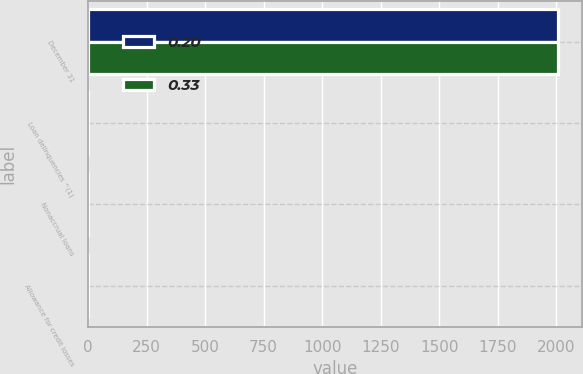Convert chart. <chart><loc_0><loc_0><loc_500><loc_500><stacked_bar_chart><ecel><fcel>December 31<fcel>Loan delinquencies ^(1)<fcel>Nonaccrual loans<fcel>Allowance for credit losses<nl><fcel>0.2<fcel>2008<fcel>0.54<fcel>0.13<fcel>0.33<nl><fcel>0.33<fcel>2007<fcel>0.8<fcel>0.12<fcel>0.2<nl></chart> 